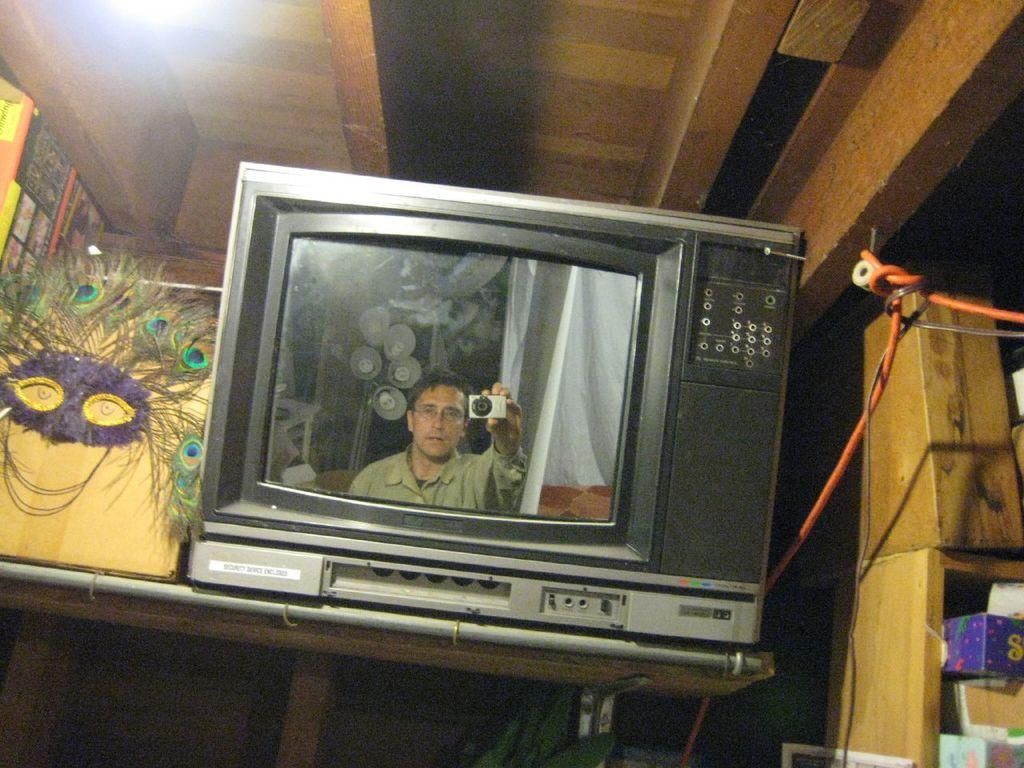What electronic device can be seen in the image? There is a television in the image. What is being displayed on the television screen? A person is visible on the television screen. What type of decorative item is present in the image? There are peacock feathers in the image. What type of items are present for reading or learning? There are books in the image. What type of storage containers are present in the image? There are boxes in the image. How much profit can be made from the scissors in the image? There are no scissors present in the image, so it is not possible to determine any potential profit. 